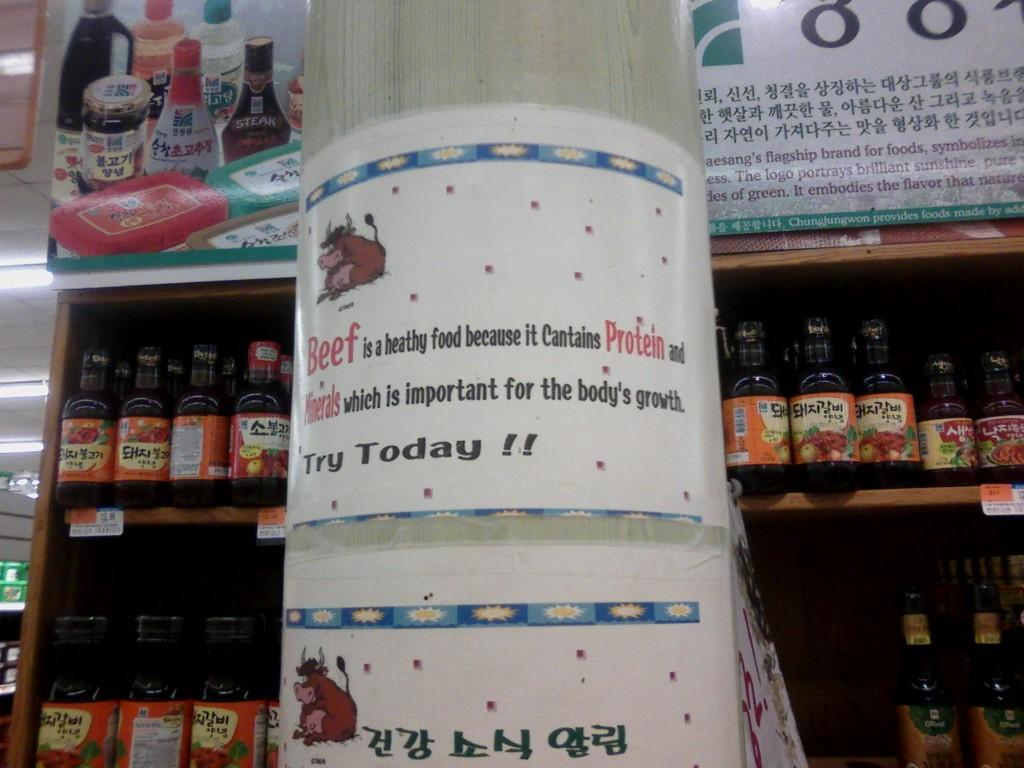<image>
Provide a brief description of the given image. Beef contains protein and minerals which is important for the body to grow. 